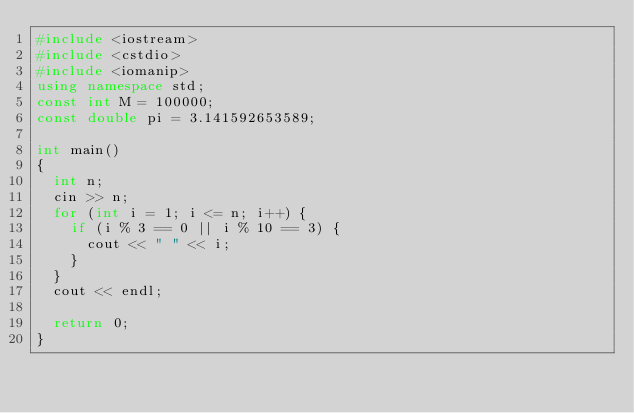Convert code to text. <code><loc_0><loc_0><loc_500><loc_500><_C++_>#include <iostream>
#include <cstdio>
#include <iomanip>
using namespace std;
const int M = 100000;
const double pi = 3.141592653589;

int main()
{
	int n;
	cin >> n;
	for (int i = 1; i <= n; i++) {
		if (i % 3 == 0 || i % 10 == 3) {
			cout << " " << i;
		}
	}
	cout << endl;

	return 0;
}</code> 